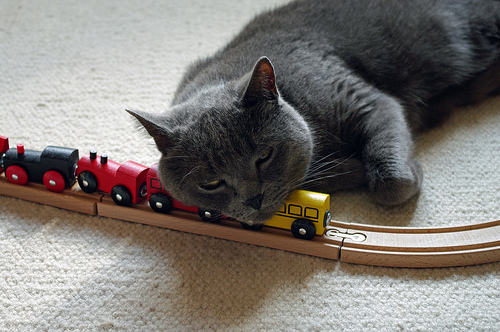<image>
Can you confirm if the cat is to the right of the train? No. The cat is not to the right of the train. The horizontal positioning shows a different relationship. 